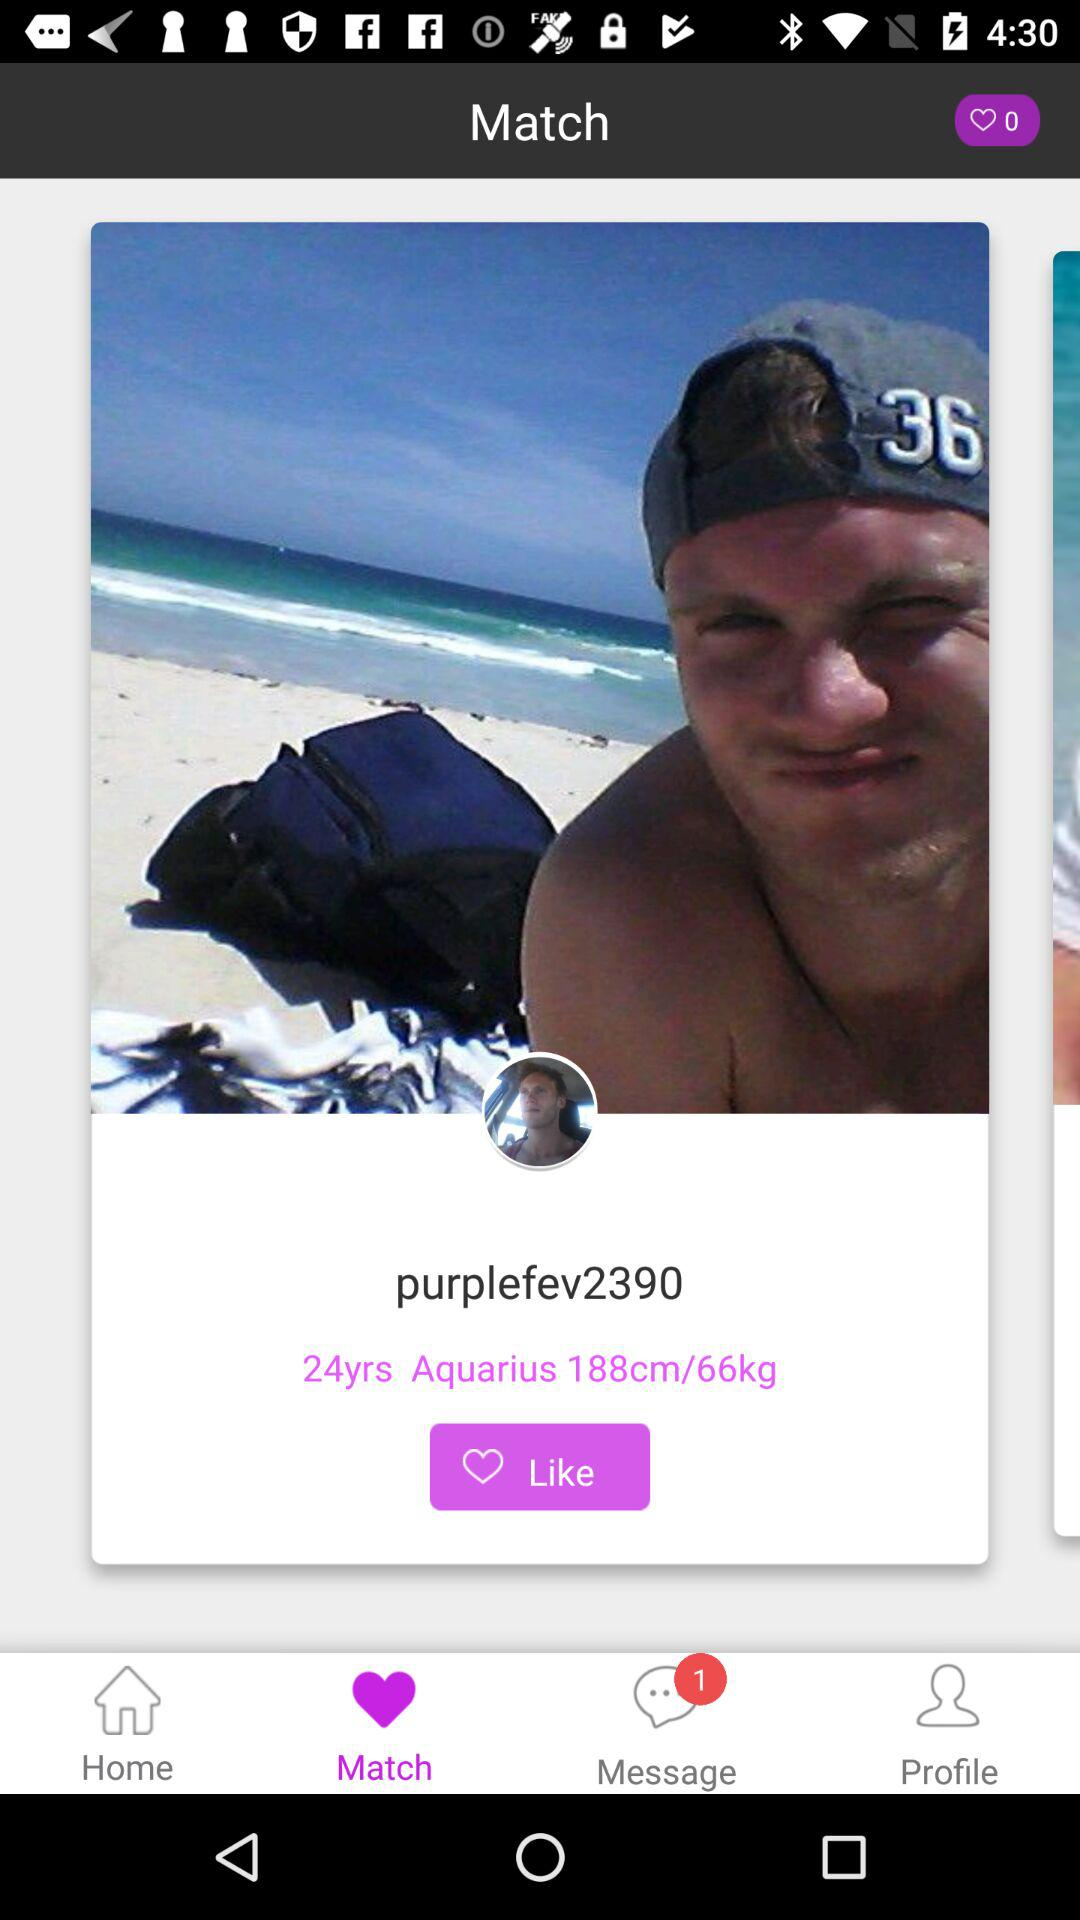What is the age of "purplefev2390"? The age is 24 years. 